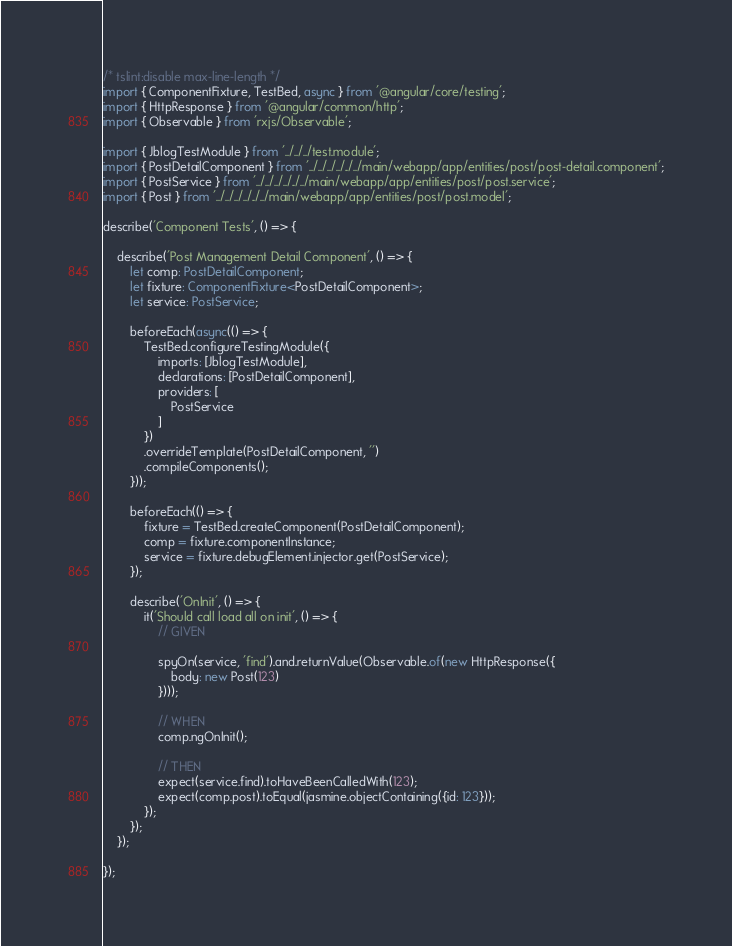Convert code to text. <code><loc_0><loc_0><loc_500><loc_500><_TypeScript_>/* tslint:disable max-line-length */
import { ComponentFixture, TestBed, async } from '@angular/core/testing';
import { HttpResponse } from '@angular/common/http';
import { Observable } from 'rxjs/Observable';

import { JblogTestModule } from '../../../test.module';
import { PostDetailComponent } from '../../../../../../main/webapp/app/entities/post/post-detail.component';
import { PostService } from '../../../../../../main/webapp/app/entities/post/post.service';
import { Post } from '../../../../../../main/webapp/app/entities/post/post.model';

describe('Component Tests', () => {

    describe('Post Management Detail Component', () => {
        let comp: PostDetailComponent;
        let fixture: ComponentFixture<PostDetailComponent>;
        let service: PostService;

        beforeEach(async(() => {
            TestBed.configureTestingModule({
                imports: [JblogTestModule],
                declarations: [PostDetailComponent],
                providers: [
                    PostService
                ]
            })
            .overrideTemplate(PostDetailComponent, '')
            .compileComponents();
        }));

        beforeEach(() => {
            fixture = TestBed.createComponent(PostDetailComponent);
            comp = fixture.componentInstance;
            service = fixture.debugElement.injector.get(PostService);
        });

        describe('OnInit', () => {
            it('Should call load all on init', () => {
                // GIVEN

                spyOn(service, 'find').and.returnValue(Observable.of(new HttpResponse({
                    body: new Post(123)
                })));

                // WHEN
                comp.ngOnInit();

                // THEN
                expect(service.find).toHaveBeenCalledWith(123);
                expect(comp.post).toEqual(jasmine.objectContaining({id: 123}));
            });
        });
    });

});
</code> 